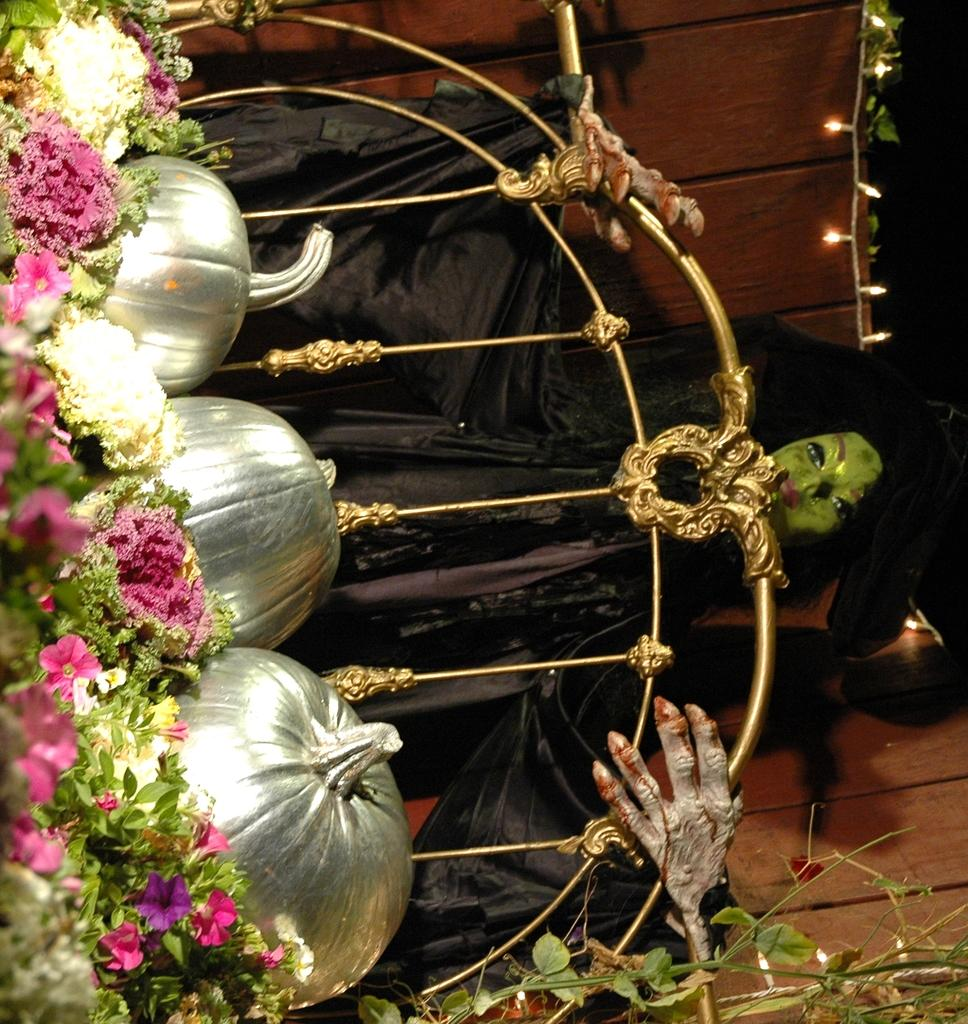What type of vegetable is present in the image? There are pumpkins in the image. What objects can be seen that are long and thin? There are rods in the image. What type of structure can be seen in the image? There is a statue in the image. What type of lighting is present in the image? There are decorative lights in the image. What type of plants are present in the image? There are flower plants in the image. What type of foliage is present in the image? There are leaves in the image. What type of wall is present in the image? There is a wooden wall in the image. What unspecified objects are present in the image? There are unspecified objects in the image. What type of clock is present in the image? There is no clock present in the image. What type of joke is being told by the statue in the image? There is no joke being told by the statue in the image. What type of finger is present in the image? There is no finger present in the image. 